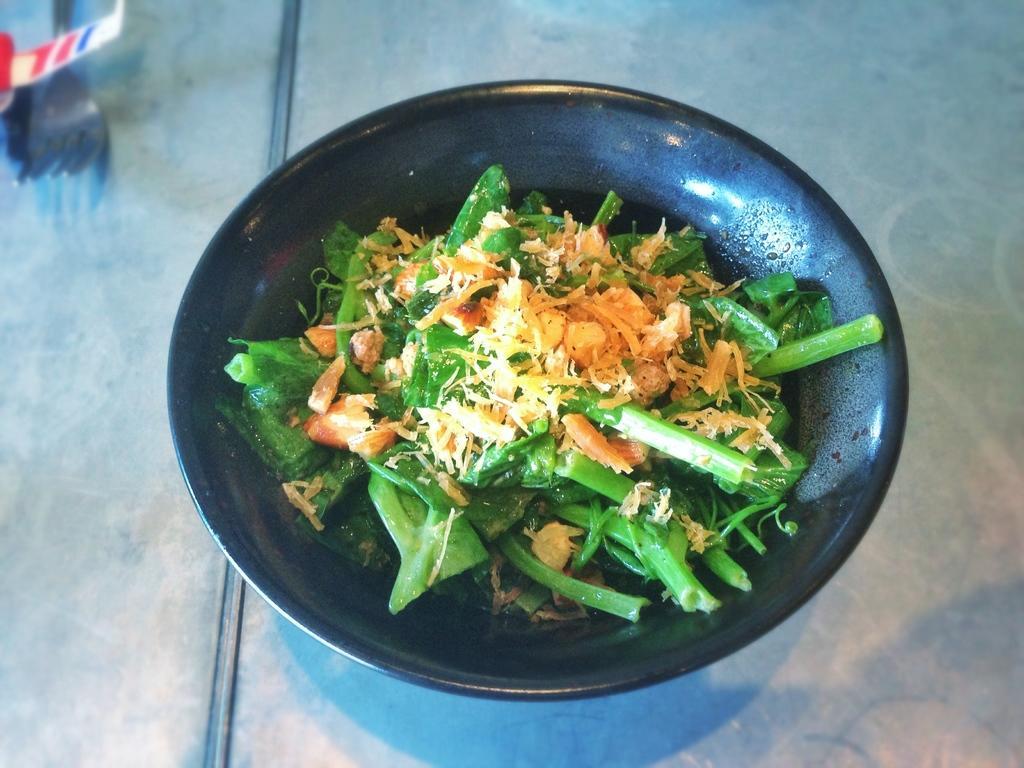Can you describe this image briefly? In this picture I can see food item in a bowl. On the left side I can see some objects. 